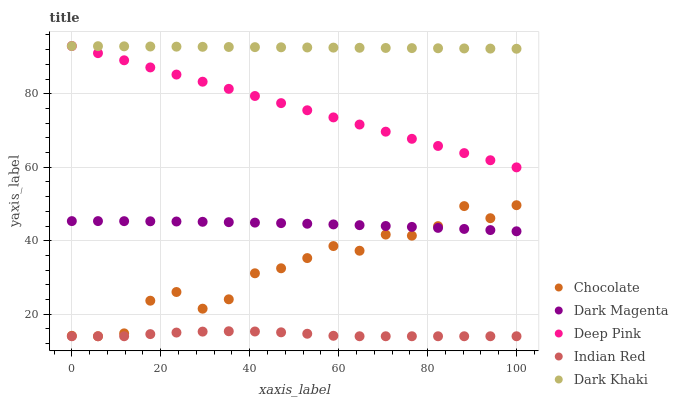Does Indian Red have the minimum area under the curve?
Answer yes or no. Yes. Does Dark Khaki have the maximum area under the curve?
Answer yes or no. Yes. Does Deep Pink have the minimum area under the curve?
Answer yes or no. No. Does Deep Pink have the maximum area under the curve?
Answer yes or no. No. Is Deep Pink the smoothest?
Answer yes or no. Yes. Is Chocolate the roughest?
Answer yes or no. Yes. Is Dark Magenta the smoothest?
Answer yes or no. No. Is Dark Magenta the roughest?
Answer yes or no. No. Does Indian Red have the lowest value?
Answer yes or no. Yes. Does Deep Pink have the lowest value?
Answer yes or no. No. Does Deep Pink have the highest value?
Answer yes or no. Yes. Does Dark Magenta have the highest value?
Answer yes or no. No. Is Dark Magenta less than Dark Khaki?
Answer yes or no. Yes. Is Deep Pink greater than Indian Red?
Answer yes or no. Yes. Does Dark Khaki intersect Deep Pink?
Answer yes or no. Yes. Is Dark Khaki less than Deep Pink?
Answer yes or no. No. Is Dark Khaki greater than Deep Pink?
Answer yes or no. No. Does Dark Magenta intersect Dark Khaki?
Answer yes or no. No. 